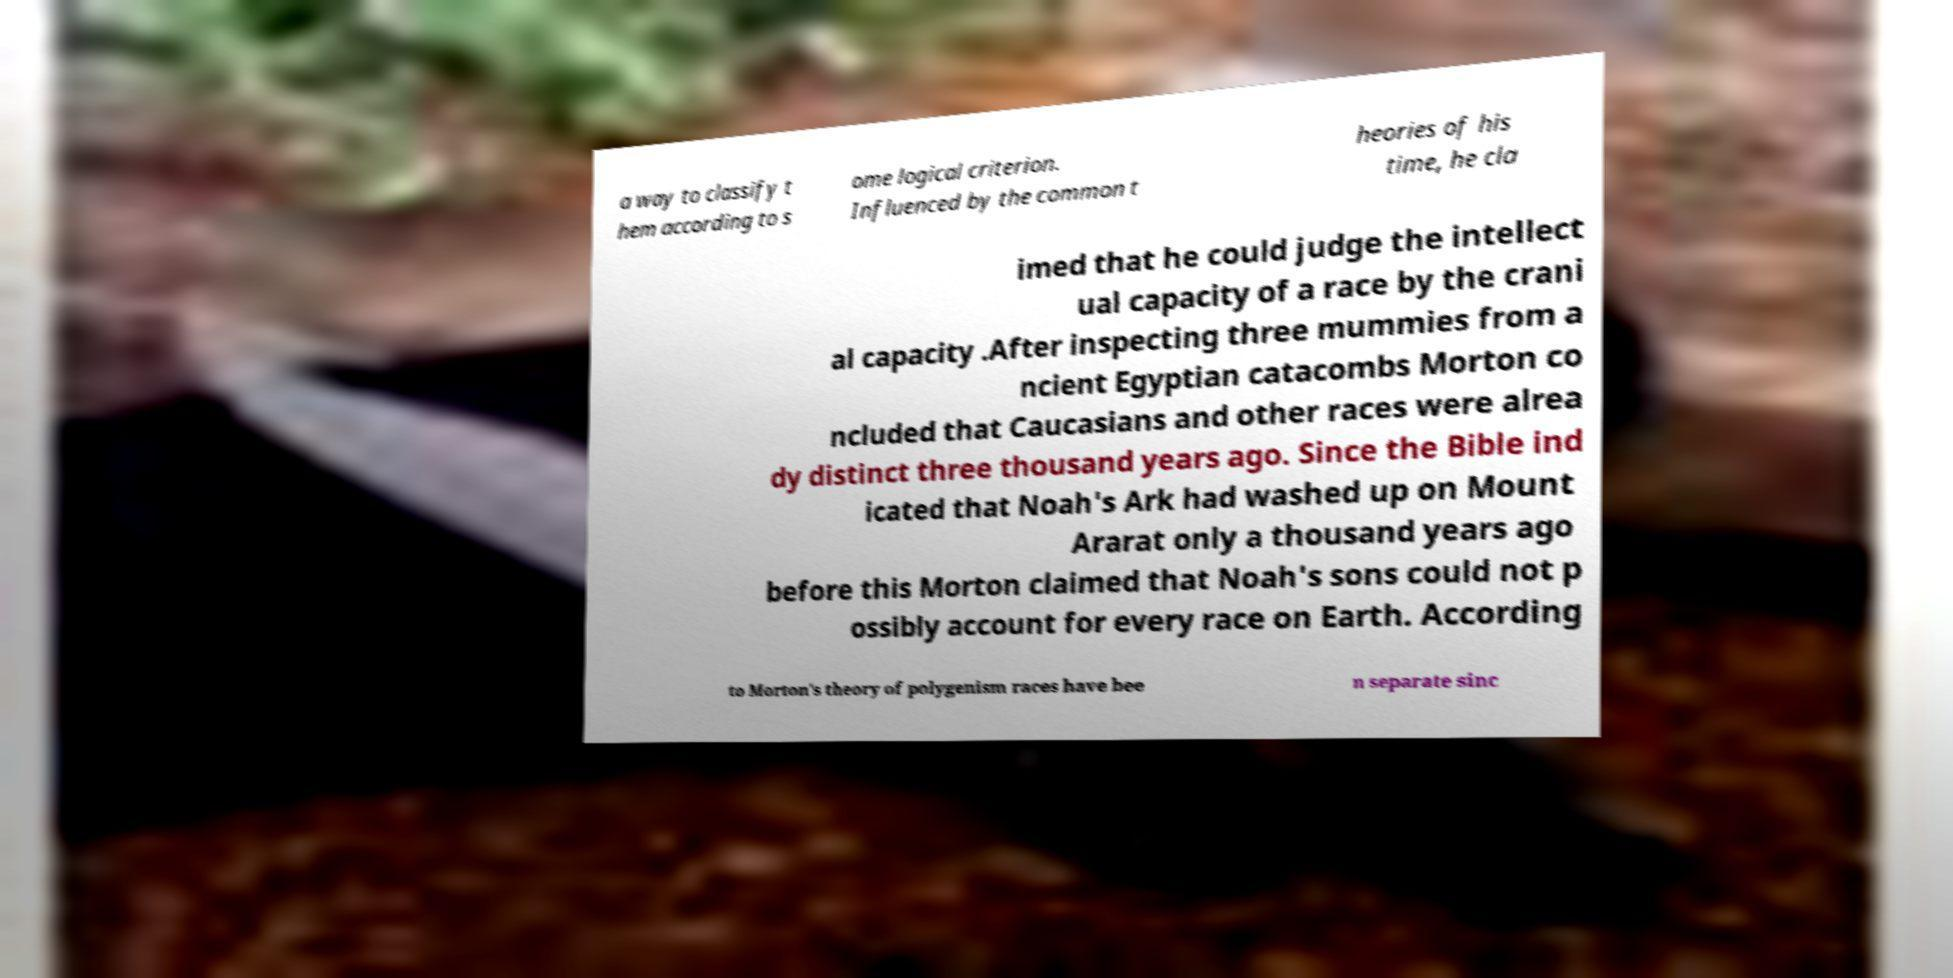Can you read and provide the text displayed in the image?This photo seems to have some interesting text. Can you extract and type it out for me? a way to classify t hem according to s ome logical criterion. Influenced by the common t heories of his time, he cla imed that he could judge the intellect ual capacity of a race by the crani al capacity .After inspecting three mummies from a ncient Egyptian catacombs Morton co ncluded that Caucasians and other races were alrea dy distinct three thousand years ago. Since the Bible ind icated that Noah's Ark had washed up on Mount Ararat only a thousand years ago before this Morton claimed that Noah's sons could not p ossibly account for every race on Earth. According to Morton's theory of polygenism races have bee n separate sinc 